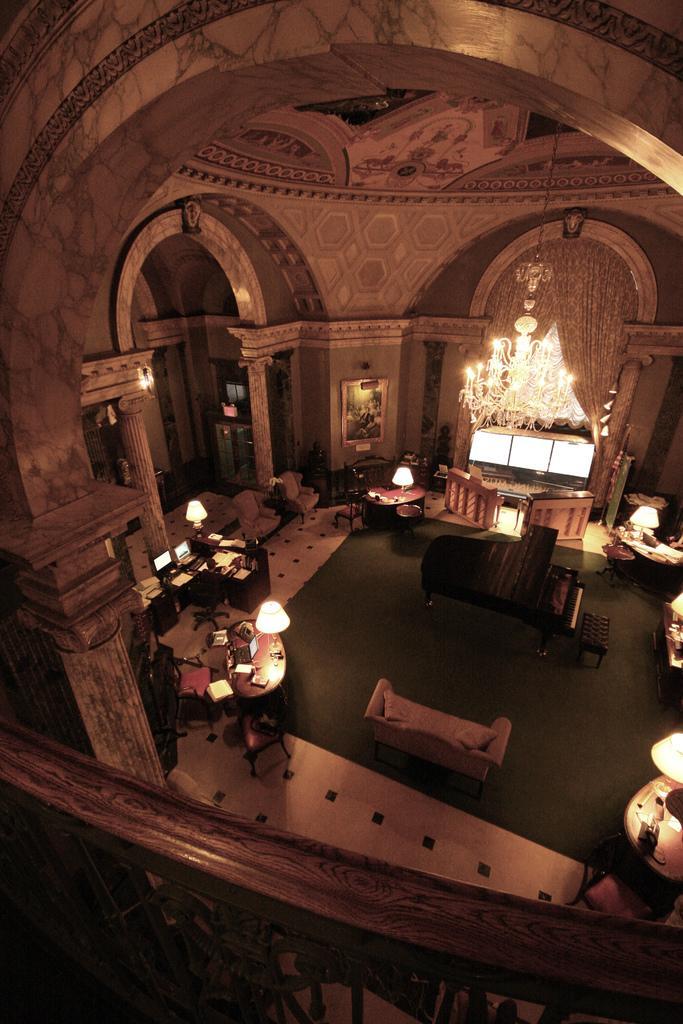Describe this image in one or two sentences. It is an inside view of a building. Here we can see walls, pillars, lights, chandelier, photo frame, few tables, chairs, piano and couch. On the tables, we can see few objects are placed on it. At the bottom, we can see a railing and floor. 